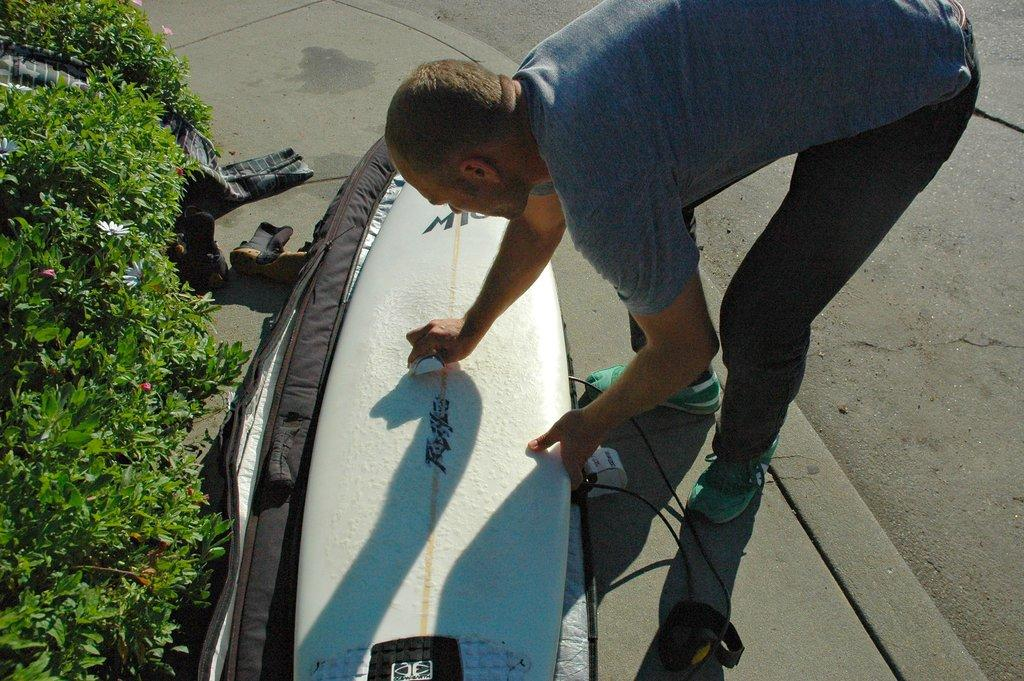What type of plants can be seen in the image? There are flower plants in the image. Who is present in the image? There is a man in the image. What is the man doing in the image? The man is bending and cleaning a surfboard. Where is the surfboard located in the image? The surfboard is on the floor. What type of tail can be seen on the man in the image? There is no tail visible on the man in the image. Who is coaching the man in the image? There is no coach present in the image; the man is cleaning the surfboard by himself. 